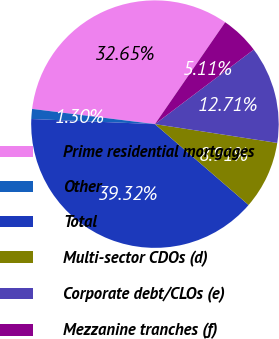Convert chart. <chart><loc_0><loc_0><loc_500><loc_500><pie_chart><fcel>Prime residential mortgages<fcel>Other<fcel>Total<fcel>Multi-sector CDOs (d)<fcel>Corporate debt/CLOs (e)<fcel>Mezzanine tranches (f)<nl><fcel>32.65%<fcel>1.3%<fcel>39.32%<fcel>8.91%<fcel>12.71%<fcel>5.11%<nl></chart> 